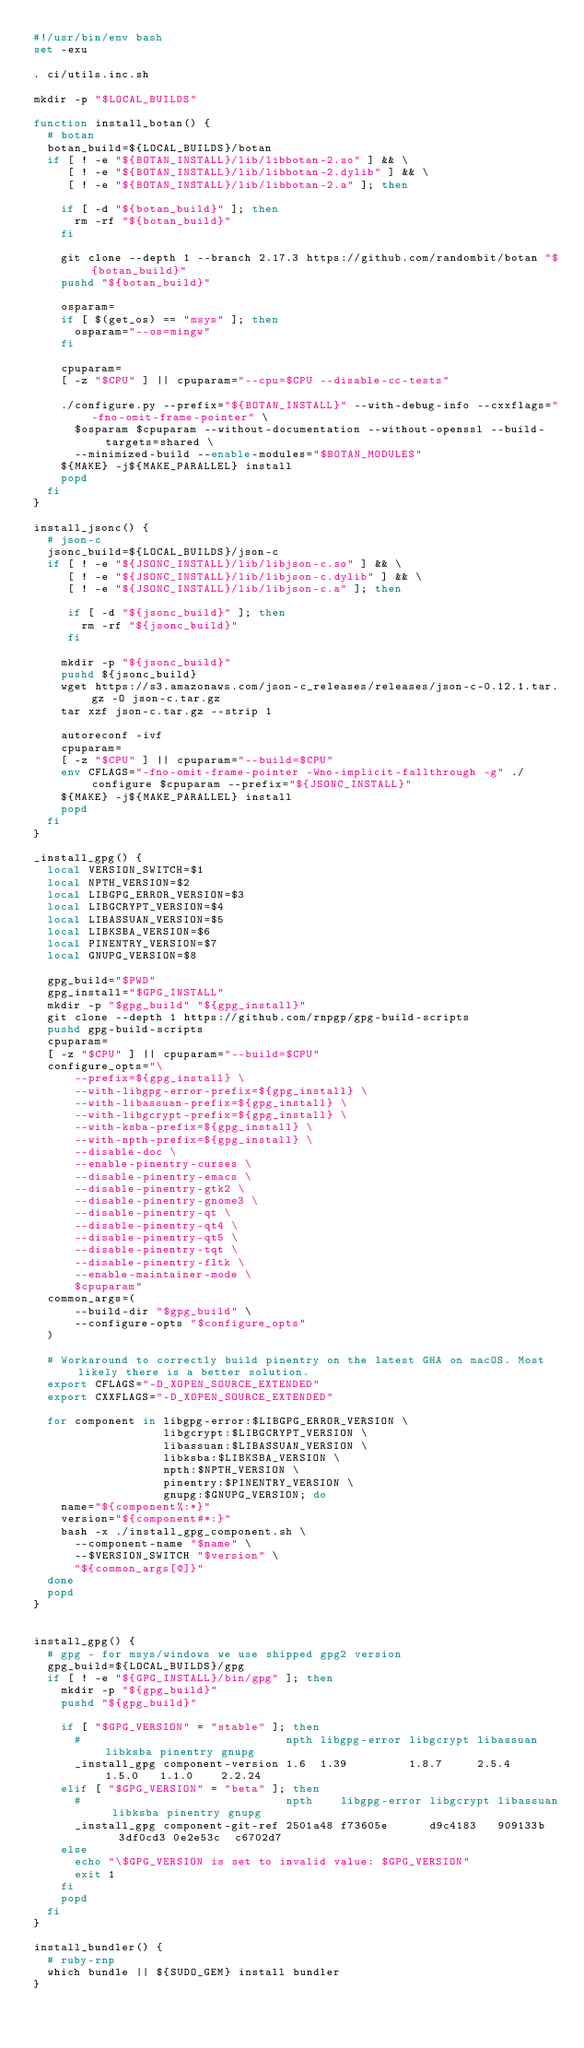<code> <loc_0><loc_0><loc_500><loc_500><_Bash_>#!/usr/bin/env bash
set -exu

. ci/utils.inc.sh

mkdir -p "$LOCAL_BUILDS"

function install_botan() {
  # botan
  botan_build=${LOCAL_BUILDS}/botan
  if [ ! -e "${BOTAN_INSTALL}/lib/libbotan-2.so" ] && \
     [ ! -e "${BOTAN_INSTALL}/lib/libbotan-2.dylib" ] && \
     [ ! -e "${BOTAN_INSTALL}/lib/libbotan-2.a" ]; then

    if [ -d "${botan_build}" ]; then
      rm -rf "${botan_build}"
    fi

    git clone --depth 1 --branch 2.17.3 https://github.com/randombit/botan "${botan_build}"
    pushd "${botan_build}"

    osparam=
    if [ $(get_os) == "msys" ]; then
      osparam="--os=mingw"
    fi

    cpuparam=
    [ -z "$CPU" ] || cpuparam="--cpu=$CPU --disable-cc-tests"

    ./configure.py --prefix="${BOTAN_INSTALL}" --with-debug-info --cxxflags="-fno-omit-frame-pointer" \
      $osparam $cpuparam --without-documentation --without-openssl --build-targets=shared \
      --minimized-build --enable-modules="$BOTAN_MODULES"
    ${MAKE} -j${MAKE_PARALLEL} install
    popd
  fi
}

install_jsonc() {
  # json-c
  jsonc_build=${LOCAL_BUILDS}/json-c
  if [ ! -e "${JSONC_INSTALL}/lib/libjson-c.so" ] && \
     [ ! -e "${JSONC_INSTALL}/lib/libjson-c.dylib" ] && \
     [ ! -e "${JSONC_INSTALL}/lib/libjson-c.a" ]; then

     if [ -d "${jsonc_build}" ]; then
       rm -rf "${jsonc_build}"
     fi

    mkdir -p "${jsonc_build}"
    pushd ${jsonc_build}
    wget https://s3.amazonaws.com/json-c_releases/releases/json-c-0.12.1.tar.gz -O json-c.tar.gz
    tar xzf json-c.tar.gz --strip 1

    autoreconf -ivf
    cpuparam=
    [ -z "$CPU" ] || cpuparam="--build=$CPU"
    env CFLAGS="-fno-omit-frame-pointer -Wno-implicit-fallthrough -g" ./configure $cpuparam --prefix="${JSONC_INSTALL}"
    ${MAKE} -j${MAKE_PARALLEL} install
    popd
  fi
}

_install_gpg() {
  local VERSION_SWITCH=$1
  local NPTH_VERSION=$2
  local LIBGPG_ERROR_VERSION=$3
  local LIBGCRYPT_VERSION=$4
  local LIBASSUAN_VERSION=$5
  local LIBKSBA_VERSION=$6
  local PINENTRY_VERSION=$7
  local GNUPG_VERSION=$8

  gpg_build="$PWD"
  gpg_install="$GPG_INSTALL"
  mkdir -p "$gpg_build" "${gpg_install}"
  git clone --depth 1 https://github.com/rnpgp/gpg-build-scripts
  pushd gpg-build-scripts
  cpuparam=
  [ -z "$CPU" ] || cpuparam="--build=$CPU"
  configure_opts="\
      --prefix=${gpg_install} \
      --with-libgpg-error-prefix=${gpg_install} \
      --with-libassuan-prefix=${gpg_install} \
      --with-libgcrypt-prefix=${gpg_install} \
      --with-ksba-prefix=${gpg_install} \
      --with-npth-prefix=${gpg_install} \
      --disable-doc \
      --enable-pinentry-curses \
      --disable-pinentry-emacs \
      --disable-pinentry-gtk2 \
      --disable-pinentry-gnome3 \
      --disable-pinentry-qt \
      --disable-pinentry-qt4 \
      --disable-pinentry-qt5 \
      --disable-pinentry-tqt \
      --disable-pinentry-fltk \
      --enable-maintainer-mode \
      $cpuparam"
  common_args=(
      --build-dir "$gpg_build" \
      --configure-opts "$configure_opts"
  )

  # Workaround to correctly build pinentry on the latest GHA on macOS. Most likely there is a better solution.
  export CFLAGS="-D_XOPEN_SOURCE_EXTENDED"
  export CXXFLAGS="-D_XOPEN_SOURCE_EXTENDED"

  for component in libgpg-error:$LIBGPG_ERROR_VERSION \
                   libgcrypt:$LIBGCRYPT_VERSION \
                   libassuan:$LIBASSUAN_VERSION \
                   libksba:$LIBKSBA_VERSION \
                   npth:$NPTH_VERSION \
                   pinentry:$PINENTRY_VERSION \
                   gnupg:$GNUPG_VERSION; do
    name="${component%:*}"
    version="${component#*:}"
    bash -x ./install_gpg_component.sh \
      --component-name "$name" \
      --$VERSION_SWITCH "$version" \
      "${common_args[@]}"
  done
  popd
}


install_gpg() {
  # gpg - for msys/windows we use shipped gpg2 version
  gpg_build=${LOCAL_BUILDS}/gpg
  if [ ! -e "${GPG_INSTALL}/bin/gpg" ]; then
    mkdir -p "${gpg_build}"
    pushd "${gpg_build}"

    if [ "$GPG_VERSION" = "stable" ]; then
      #                              npth libgpg-error libgcrypt libassuan libksba pinentry gnupg
      _install_gpg component-version 1.6  1.39         1.8.7     2.5.4     1.5.0   1.1.0    2.2.24
    elif [ "$GPG_VERSION" = "beta" ]; then
      #                              npth    libgpg-error libgcrypt libassuan libksba pinentry gnupg
      _install_gpg component-git-ref 2501a48 f73605e      d9c4183   909133b   3df0cd3 0e2e53c  c6702d7
    else
      echo "\$GPG_VERSION is set to invalid value: $GPG_VERSION"
      exit 1
    fi
    popd
  fi
}

install_bundler() {
  # ruby-rnp
  which bundle || ${SUDO_GEM} install bundler
}
</code> 